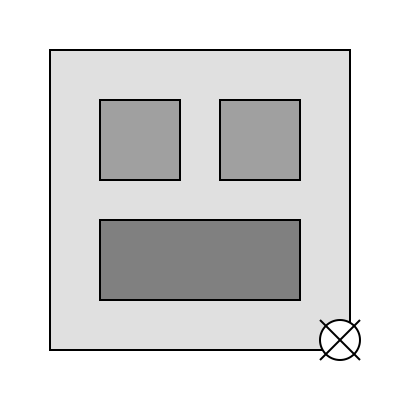Based on the satellite imagery provided, what type of military structure is most likely represented, and what key features support this identification? To identify the military structure in the satellite imagery, we need to analyze the key features:

1. Overall layout: The image shows a large rectangular area, indicating a controlled or restricted space.

2. Building structures:
   a. Two smaller square structures at the top (likely barracks or administrative buildings)
   b. One larger rectangular structure at the bottom (possibly a hangar or maintenance facility)

3. Open space: There's a significant open area, which could be used for vehicle parking, aircraft taxiing, or troop formations.

4. Distinct feature: A circular object with crossed lines in the bottom-right corner, resembling a radar or communication dish.

5. Perimeter: The entire area is enclosed, suggesting a secure facility.

Given these features, the most likely military structure represented is an airfield or air base. The key supporting features are:

1. The large rectangular structure resembling an aircraft hangar
2. The open space that could serve as a taxiway or apron
3. The radar-like structure for air traffic control or surveillance
4. The overall enclosed layout typical of military installations

As a war correspondent, recognizing these features is crucial for accurately reporting on military infrastructure and operations.
Answer: Air base/Airfield; Features: hangar-like structure, open space for aircraft, radar-like object, enclosed perimeter 